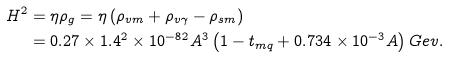Convert formula to latex. <formula><loc_0><loc_0><loc_500><loc_500>H ^ { 2 } & = \eta \rho _ { g } = \eta \left ( \rho _ { v m } + \rho _ { v \gamma } - \rho _ { s m } \right ) \\ & = 0 . 2 7 \times 1 . 4 ^ { 2 } \times 1 0 ^ { - 8 2 } A ^ { 3 } \left ( 1 - t _ { m q } + 0 . 7 3 4 \times 1 0 ^ { - 3 } A \right ) G e v .</formula> 